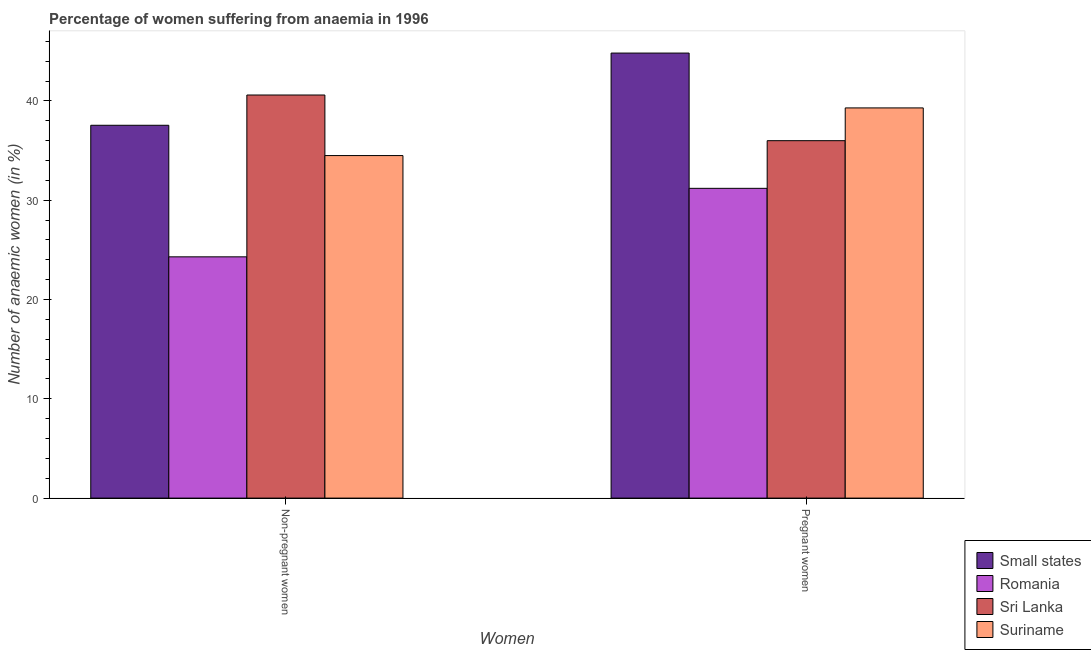How many bars are there on the 2nd tick from the left?
Offer a very short reply. 4. What is the label of the 2nd group of bars from the left?
Your answer should be compact. Pregnant women. What is the percentage of non-pregnant anaemic women in Suriname?
Give a very brief answer. 34.5. Across all countries, what is the maximum percentage of pregnant anaemic women?
Offer a very short reply. 44.82. Across all countries, what is the minimum percentage of non-pregnant anaemic women?
Keep it short and to the point. 24.3. In which country was the percentage of pregnant anaemic women maximum?
Your answer should be very brief. Small states. In which country was the percentage of pregnant anaemic women minimum?
Offer a terse response. Romania. What is the total percentage of non-pregnant anaemic women in the graph?
Give a very brief answer. 136.95. What is the difference between the percentage of pregnant anaemic women in Sri Lanka and that in Romania?
Your answer should be very brief. 4.8. What is the difference between the percentage of pregnant anaemic women in Sri Lanka and the percentage of non-pregnant anaemic women in Small states?
Make the answer very short. -1.55. What is the average percentage of pregnant anaemic women per country?
Offer a very short reply. 37.83. What is the difference between the percentage of non-pregnant anaemic women and percentage of pregnant anaemic women in Small states?
Make the answer very short. -7.27. What is the ratio of the percentage of pregnant anaemic women in Sri Lanka to that in Suriname?
Provide a short and direct response. 0.92. Is the percentage of non-pregnant anaemic women in Sri Lanka less than that in Small states?
Make the answer very short. No. In how many countries, is the percentage of non-pregnant anaemic women greater than the average percentage of non-pregnant anaemic women taken over all countries?
Ensure brevity in your answer.  3. What does the 4th bar from the left in Pregnant women represents?
Provide a succinct answer. Suriname. What does the 3rd bar from the right in Pregnant women represents?
Your response must be concise. Romania. How many bars are there?
Offer a very short reply. 8. What is the difference between two consecutive major ticks on the Y-axis?
Your response must be concise. 10. Does the graph contain any zero values?
Provide a succinct answer. No. Does the graph contain grids?
Your answer should be very brief. No. How many legend labels are there?
Your answer should be very brief. 4. How are the legend labels stacked?
Your answer should be very brief. Vertical. What is the title of the graph?
Give a very brief answer. Percentage of women suffering from anaemia in 1996. Does "Curacao" appear as one of the legend labels in the graph?
Offer a terse response. No. What is the label or title of the X-axis?
Keep it short and to the point. Women. What is the label or title of the Y-axis?
Keep it short and to the point. Number of anaemic women (in %). What is the Number of anaemic women (in %) in Small states in Non-pregnant women?
Ensure brevity in your answer.  37.55. What is the Number of anaemic women (in %) in Romania in Non-pregnant women?
Your answer should be compact. 24.3. What is the Number of anaemic women (in %) in Sri Lanka in Non-pregnant women?
Make the answer very short. 40.6. What is the Number of anaemic women (in %) of Suriname in Non-pregnant women?
Your response must be concise. 34.5. What is the Number of anaemic women (in %) in Small states in Pregnant women?
Offer a very short reply. 44.82. What is the Number of anaemic women (in %) in Romania in Pregnant women?
Offer a very short reply. 31.2. What is the Number of anaemic women (in %) in Suriname in Pregnant women?
Provide a short and direct response. 39.3. Across all Women, what is the maximum Number of anaemic women (in %) of Small states?
Make the answer very short. 44.82. Across all Women, what is the maximum Number of anaemic women (in %) in Romania?
Offer a terse response. 31.2. Across all Women, what is the maximum Number of anaemic women (in %) in Sri Lanka?
Your answer should be very brief. 40.6. Across all Women, what is the maximum Number of anaemic women (in %) of Suriname?
Your response must be concise. 39.3. Across all Women, what is the minimum Number of anaemic women (in %) of Small states?
Your answer should be very brief. 37.55. Across all Women, what is the minimum Number of anaemic women (in %) of Romania?
Keep it short and to the point. 24.3. Across all Women, what is the minimum Number of anaemic women (in %) in Suriname?
Your answer should be compact. 34.5. What is the total Number of anaemic women (in %) in Small states in the graph?
Your answer should be very brief. 82.38. What is the total Number of anaemic women (in %) in Romania in the graph?
Keep it short and to the point. 55.5. What is the total Number of anaemic women (in %) of Sri Lanka in the graph?
Your response must be concise. 76.6. What is the total Number of anaemic women (in %) of Suriname in the graph?
Ensure brevity in your answer.  73.8. What is the difference between the Number of anaemic women (in %) in Small states in Non-pregnant women and that in Pregnant women?
Ensure brevity in your answer.  -7.27. What is the difference between the Number of anaemic women (in %) in Sri Lanka in Non-pregnant women and that in Pregnant women?
Make the answer very short. 4.6. What is the difference between the Number of anaemic women (in %) of Small states in Non-pregnant women and the Number of anaemic women (in %) of Romania in Pregnant women?
Provide a succinct answer. 6.35. What is the difference between the Number of anaemic women (in %) of Small states in Non-pregnant women and the Number of anaemic women (in %) of Sri Lanka in Pregnant women?
Provide a succinct answer. 1.55. What is the difference between the Number of anaemic women (in %) of Small states in Non-pregnant women and the Number of anaemic women (in %) of Suriname in Pregnant women?
Your answer should be compact. -1.75. What is the difference between the Number of anaemic women (in %) in Romania in Non-pregnant women and the Number of anaemic women (in %) in Suriname in Pregnant women?
Provide a succinct answer. -15. What is the difference between the Number of anaemic women (in %) in Sri Lanka in Non-pregnant women and the Number of anaemic women (in %) in Suriname in Pregnant women?
Keep it short and to the point. 1.3. What is the average Number of anaemic women (in %) of Small states per Women?
Give a very brief answer. 41.19. What is the average Number of anaemic women (in %) in Romania per Women?
Ensure brevity in your answer.  27.75. What is the average Number of anaemic women (in %) in Sri Lanka per Women?
Make the answer very short. 38.3. What is the average Number of anaemic women (in %) of Suriname per Women?
Offer a very short reply. 36.9. What is the difference between the Number of anaemic women (in %) of Small states and Number of anaemic women (in %) of Romania in Non-pregnant women?
Provide a short and direct response. 13.25. What is the difference between the Number of anaemic women (in %) of Small states and Number of anaemic women (in %) of Sri Lanka in Non-pregnant women?
Provide a short and direct response. -3.05. What is the difference between the Number of anaemic women (in %) in Small states and Number of anaemic women (in %) in Suriname in Non-pregnant women?
Provide a short and direct response. 3.05. What is the difference between the Number of anaemic women (in %) in Romania and Number of anaemic women (in %) in Sri Lanka in Non-pregnant women?
Ensure brevity in your answer.  -16.3. What is the difference between the Number of anaemic women (in %) of Romania and Number of anaemic women (in %) of Suriname in Non-pregnant women?
Keep it short and to the point. -10.2. What is the difference between the Number of anaemic women (in %) of Small states and Number of anaemic women (in %) of Romania in Pregnant women?
Ensure brevity in your answer.  13.62. What is the difference between the Number of anaemic women (in %) in Small states and Number of anaemic women (in %) in Sri Lanka in Pregnant women?
Ensure brevity in your answer.  8.82. What is the difference between the Number of anaemic women (in %) of Small states and Number of anaemic women (in %) of Suriname in Pregnant women?
Your response must be concise. 5.52. What is the difference between the Number of anaemic women (in %) of Romania and Number of anaemic women (in %) of Sri Lanka in Pregnant women?
Your answer should be very brief. -4.8. What is the difference between the Number of anaemic women (in %) in Sri Lanka and Number of anaemic women (in %) in Suriname in Pregnant women?
Offer a very short reply. -3.3. What is the ratio of the Number of anaemic women (in %) of Small states in Non-pregnant women to that in Pregnant women?
Ensure brevity in your answer.  0.84. What is the ratio of the Number of anaemic women (in %) of Romania in Non-pregnant women to that in Pregnant women?
Your answer should be very brief. 0.78. What is the ratio of the Number of anaemic women (in %) of Sri Lanka in Non-pregnant women to that in Pregnant women?
Your answer should be very brief. 1.13. What is the ratio of the Number of anaemic women (in %) in Suriname in Non-pregnant women to that in Pregnant women?
Offer a terse response. 0.88. What is the difference between the highest and the second highest Number of anaemic women (in %) in Small states?
Make the answer very short. 7.27. What is the difference between the highest and the second highest Number of anaemic women (in %) in Suriname?
Keep it short and to the point. 4.8. What is the difference between the highest and the lowest Number of anaemic women (in %) in Small states?
Give a very brief answer. 7.27. What is the difference between the highest and the lowest Number of anaemic women (in %) in Sri Lanka?
Provide a short and direct response. 4.6. What is the difference between the highest and the lowest Number of anaemic women (in %) of Suriname?
Give a very brief answer. 4.8. 